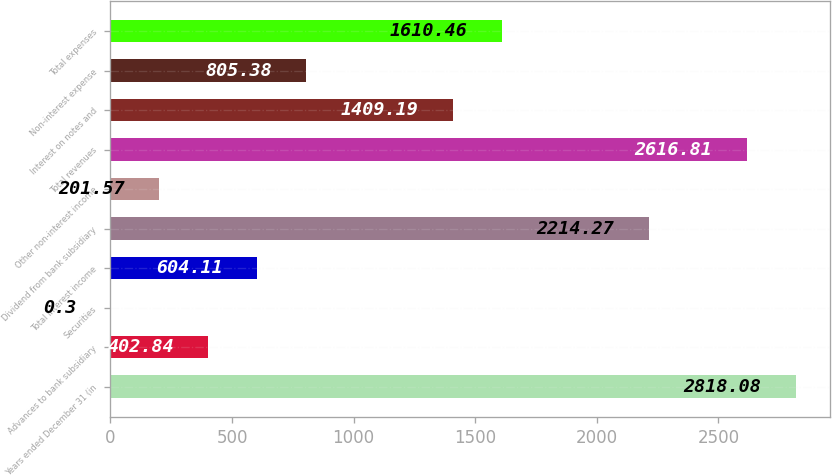Convert chart. <chart><loc_0><loc_0><loc_500><loc_500><bar_chart><fcel>Years ended December 31 (in<fcel>Advances to bank subsidiary<fcel>Securities<fcel>Total interest income<fcel>Dividend from bank subsidiary<fcel>Other non-interest income<fcel>Total revenues<fcel>Interest on notes and<fcel>Non-interest expense<fcel>Total expenses<nl><fcel>2818.08<fcel>402.84<fcel>0.3<fcel>604.11<fcel>2214.27<fcel>201.57<fcel>2616.81<fcel>1409.19<fcel>805.38<fcel>1610.46<nl></chart> 